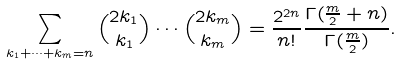<formula> <loc_0><loc_0><loc_500><loc_500>\sum _ { k _ { 1 } + \cdots + k _ { m } = n } \binom { 2 k _ { 1 } } { k _ { 1 } } \cdots \binom { 2 k _ { m } } { k _ { m } } = \frac { 2 ^ { 2 n } } { n ! } \frac { \Gamma ( \frac { m } { 2 } + n ) } { \Gamma ( \frac { m } { 2 } ) } .</formula> 